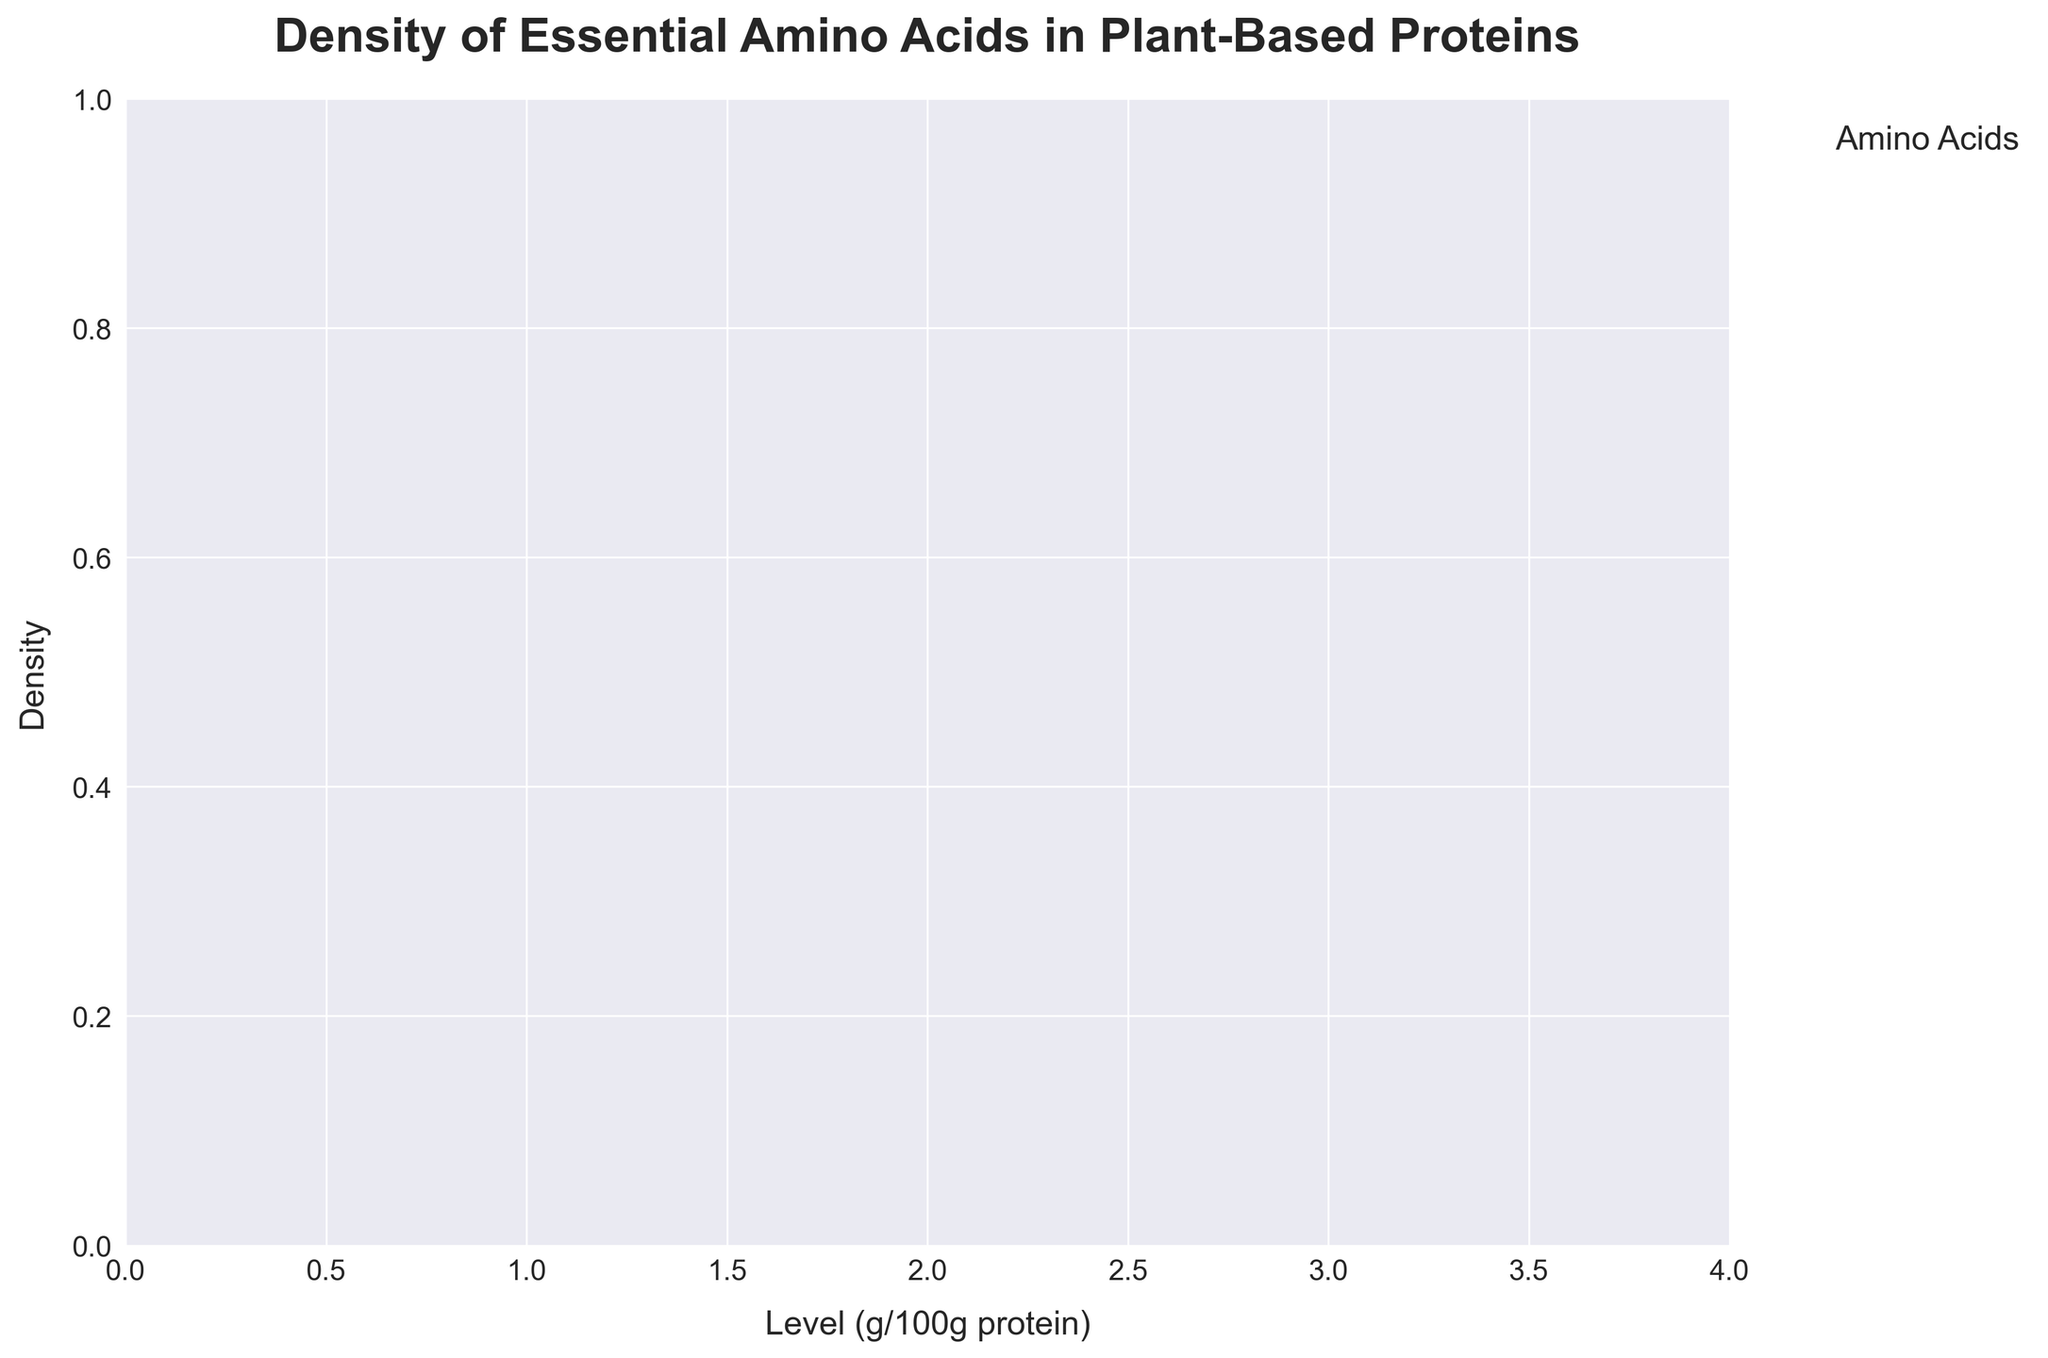What is the title of the plot? The title of the plot is prominently displayed at the top, stating "Density of Essential Amino Acids in Plant-Based Proteins."
Answer: Density of Essential Amino Acids in Plant-Based Proteins What does the x-axis represent? The x-axis is labeled "Level (g/100g protein)," indicating it shows the levels of essential amino acids per 100 grams of protein.
Answer: Level (g/100g protein) Are there any proteins that have a density range for any amino acid that extends to the rightmost part of the x-axis (near 4)? By examining the density overlay for all proteins, it is noticeable that none of the density plots extend as far as 4 on the x-axis. They predominantly peak below 3.5.
Answer: No Which amino acid shows the highest density spike in Soy Protein? Looking at the density plot for Soy Protein, the amino acid with the highest density spike is Leucine, shown by the peak height.
Answer: Leucine Which plant-based protein exhibits a significant density for Lysine around 2.5? Examining the complete density plots for all proteins, it is clear that both Soy Protein and Pea Protein have significant density peaks for Lysine around the 2.5 level.
Answer: Soy Protein and Pea Protein Which protein has the lowest density for Threonine below 1.0? The density plot for Threonine shows that Hemp Protein has the lowest density below the 1.0 level.
Answer: Hemp Protein Compare the densities of Methionine in Rice Protein and Hemp Protein. Which one is higher? By analyzing the overlaps in density, Rice Protein exhibits a higher density for Methionine compared to Hemp Protein.
Answer: Rice Protein What is the range of Leucine levels across all plant-based proteins? Observing the end-to-end spread of density peaks for Leucine, the range spans approximately from 2.2 to 3.5.
Answer: 2.2 to 3.5 Are there any amino acids where Quinoa Protein shows multiple density peaks, and which amino acid if any? The density plot of Quinoa Protein shows multiple subtle peaks for the amino acid Phenylalanine.
Answer: Phenylalanine 